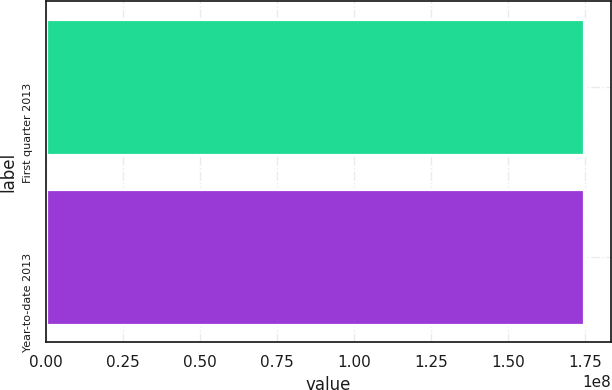<chart> <loc_0><loc_0><loc_500><loc_500><bar_chart><fcel>First quarter 2013<fcel>Year-to-date 2013<nl><fcel>1.74828e+08<fcel>1.74828e+08<nl></chart> 